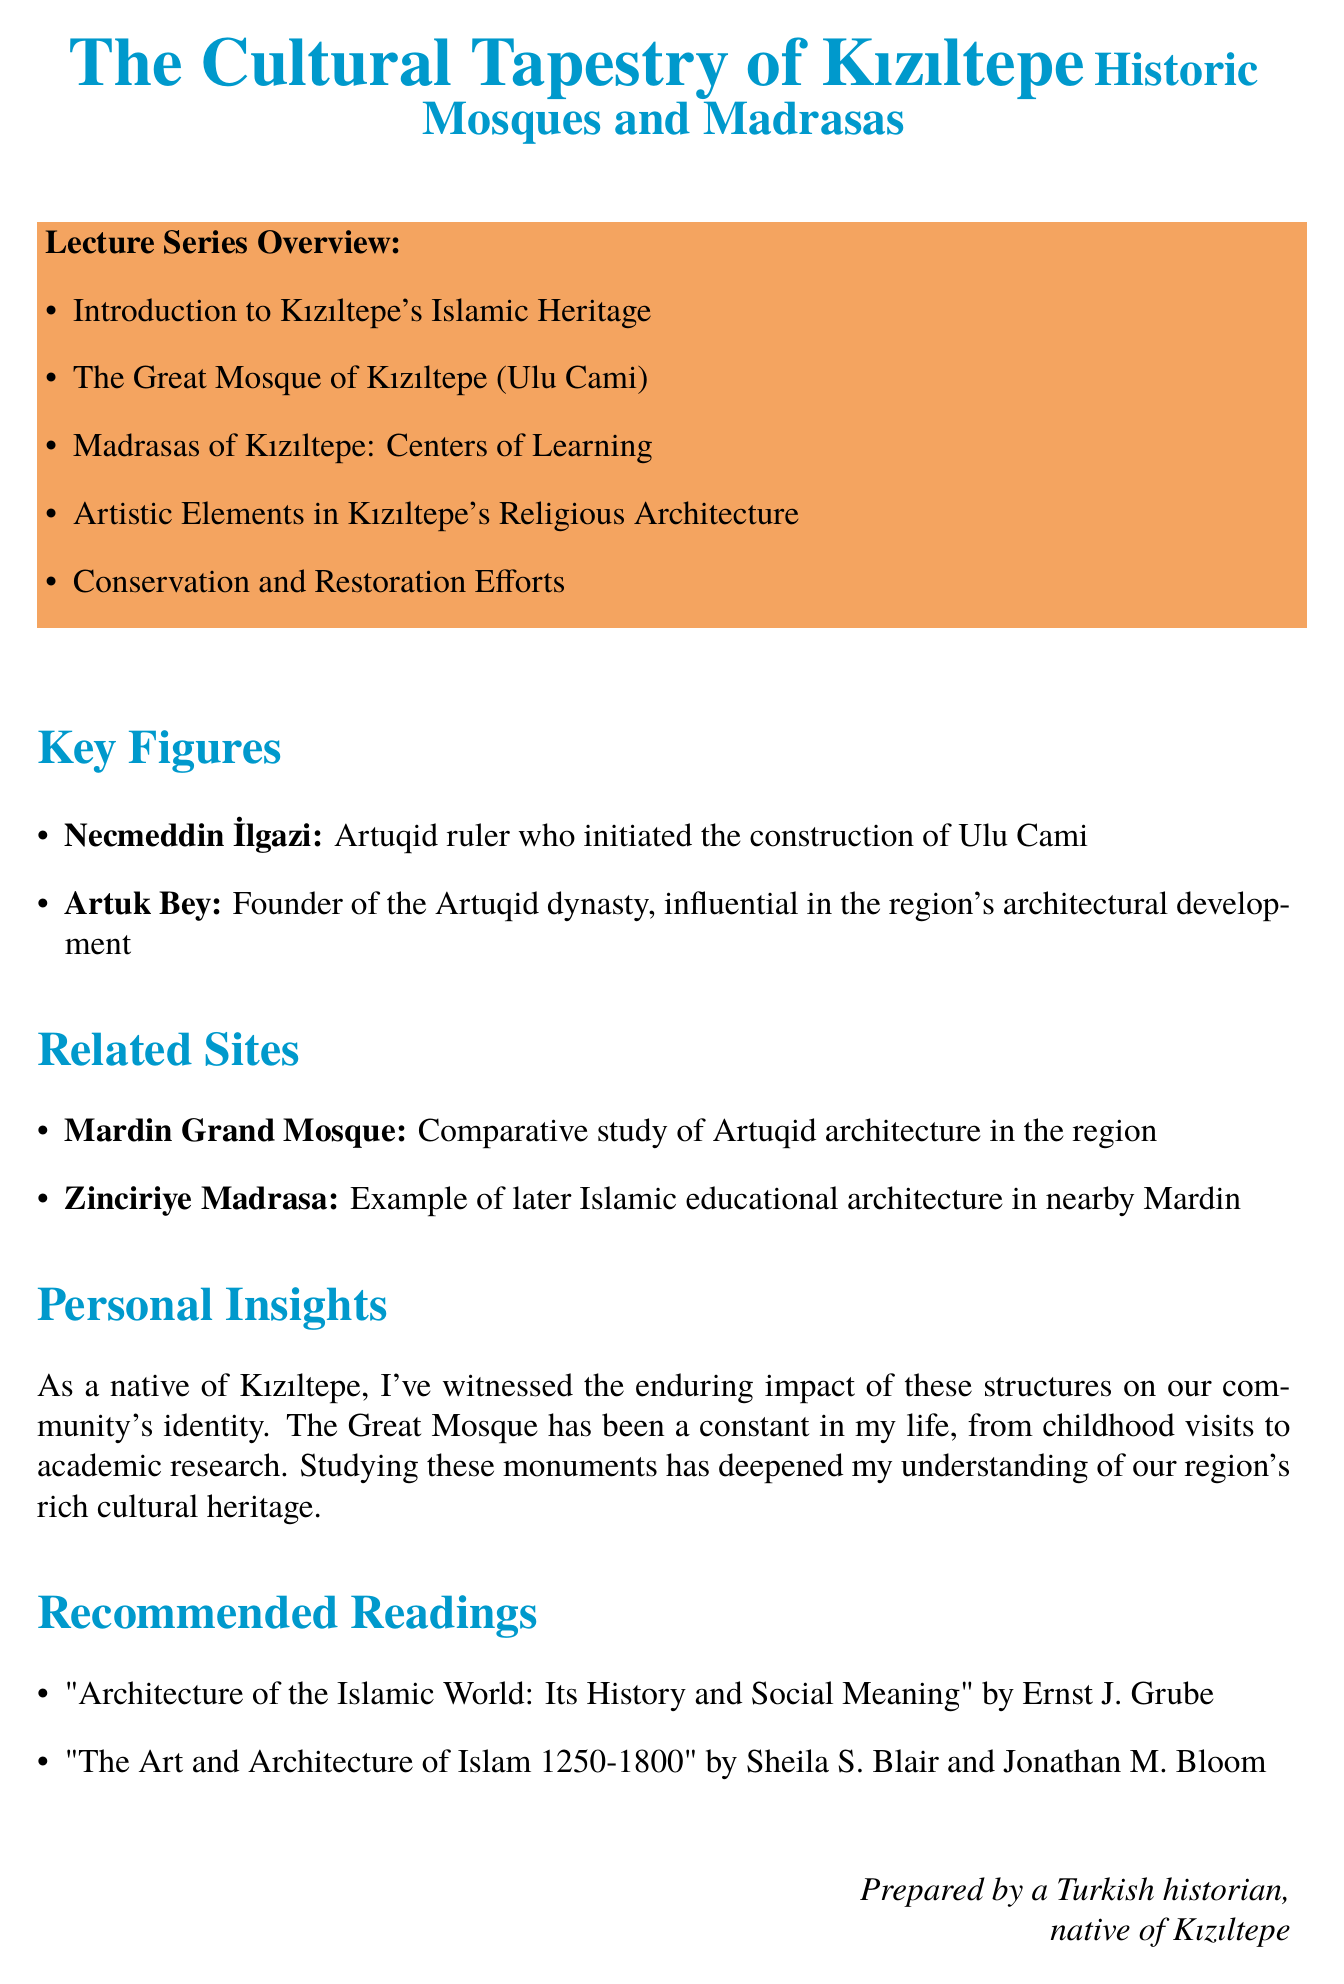what is the title of the lecture series? The title of the lecture series is stated at the beginning of the document.
Answer: The Cultural Tapestry of Kızıltepe: Historic Mosques and Madrasas who initiated the construction of Ulu Cami? The document mentions key figures and their contributions; therefore, I can find the answer.
Answer: Necmeddin İlgazi which madrasa is specifically mentioned in Kızıltepe? The lecture about madrasas includes specific institutions relevant to Kızıltepe.
Answer: Taceddin Mesud Madrasa what is the significance of madrasas in the document? The overview of madrasas discusses their role in education, providing insight into their importance in society.
Answer: Islamic education name one artistic element discussed in Kızıltepe's architecture. The specific lecture about artistic elements lists various aspects of the architecture.
Answer: Calligraphy what challenges are mentioned regarding conservation efforts? The section on conservation and restoration outlines various issues faced in preserving historic structures.
Answer: Challenges in preserving historic structures how many lectures are listed in the series? Counting the items in the overview section confirms the total number of lectures included in the series.
Answer: Five who are the authors of the recommended readings? The document includes a list of suggested readings along with their respective authors.
Answer: Ernst J. Grube; Sheila S. Blair and Jonathan M. Bloom 